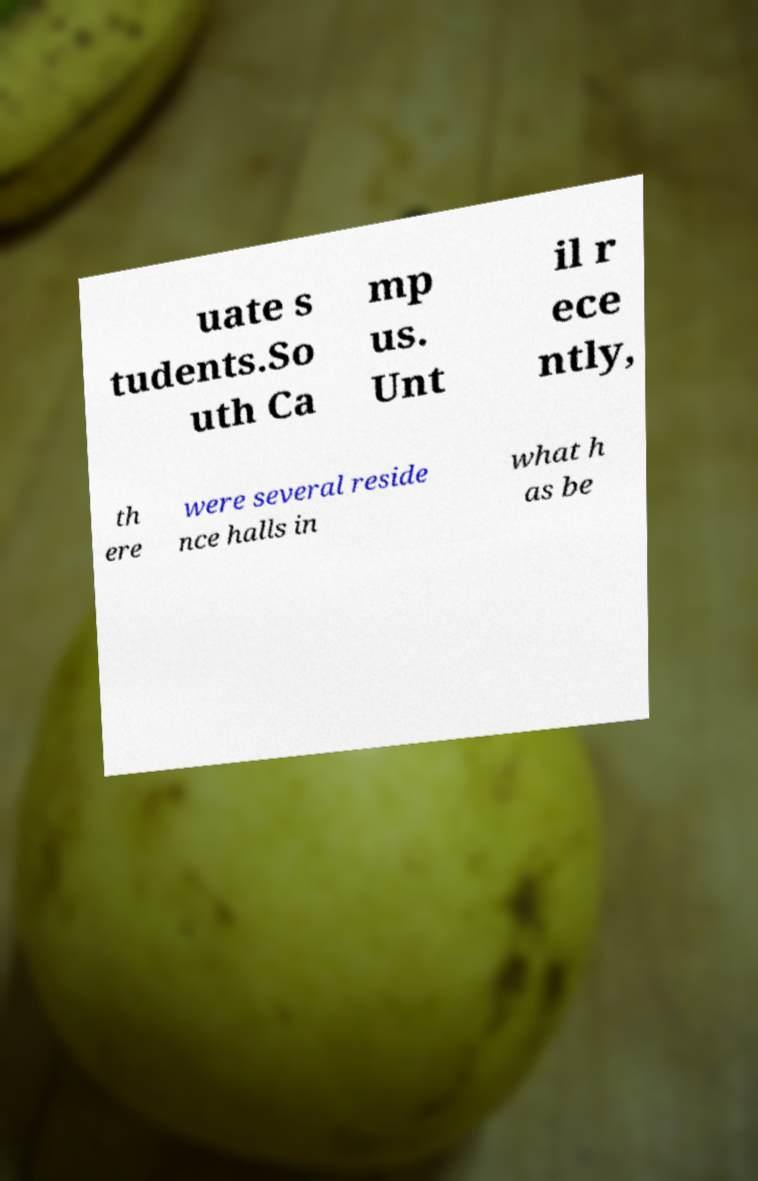Please identify and transcribe the text found in this image. uate s tudents.So uth Ca mp us. Unt il r ece ntly, th ere were several reside nce halls in what h as be 